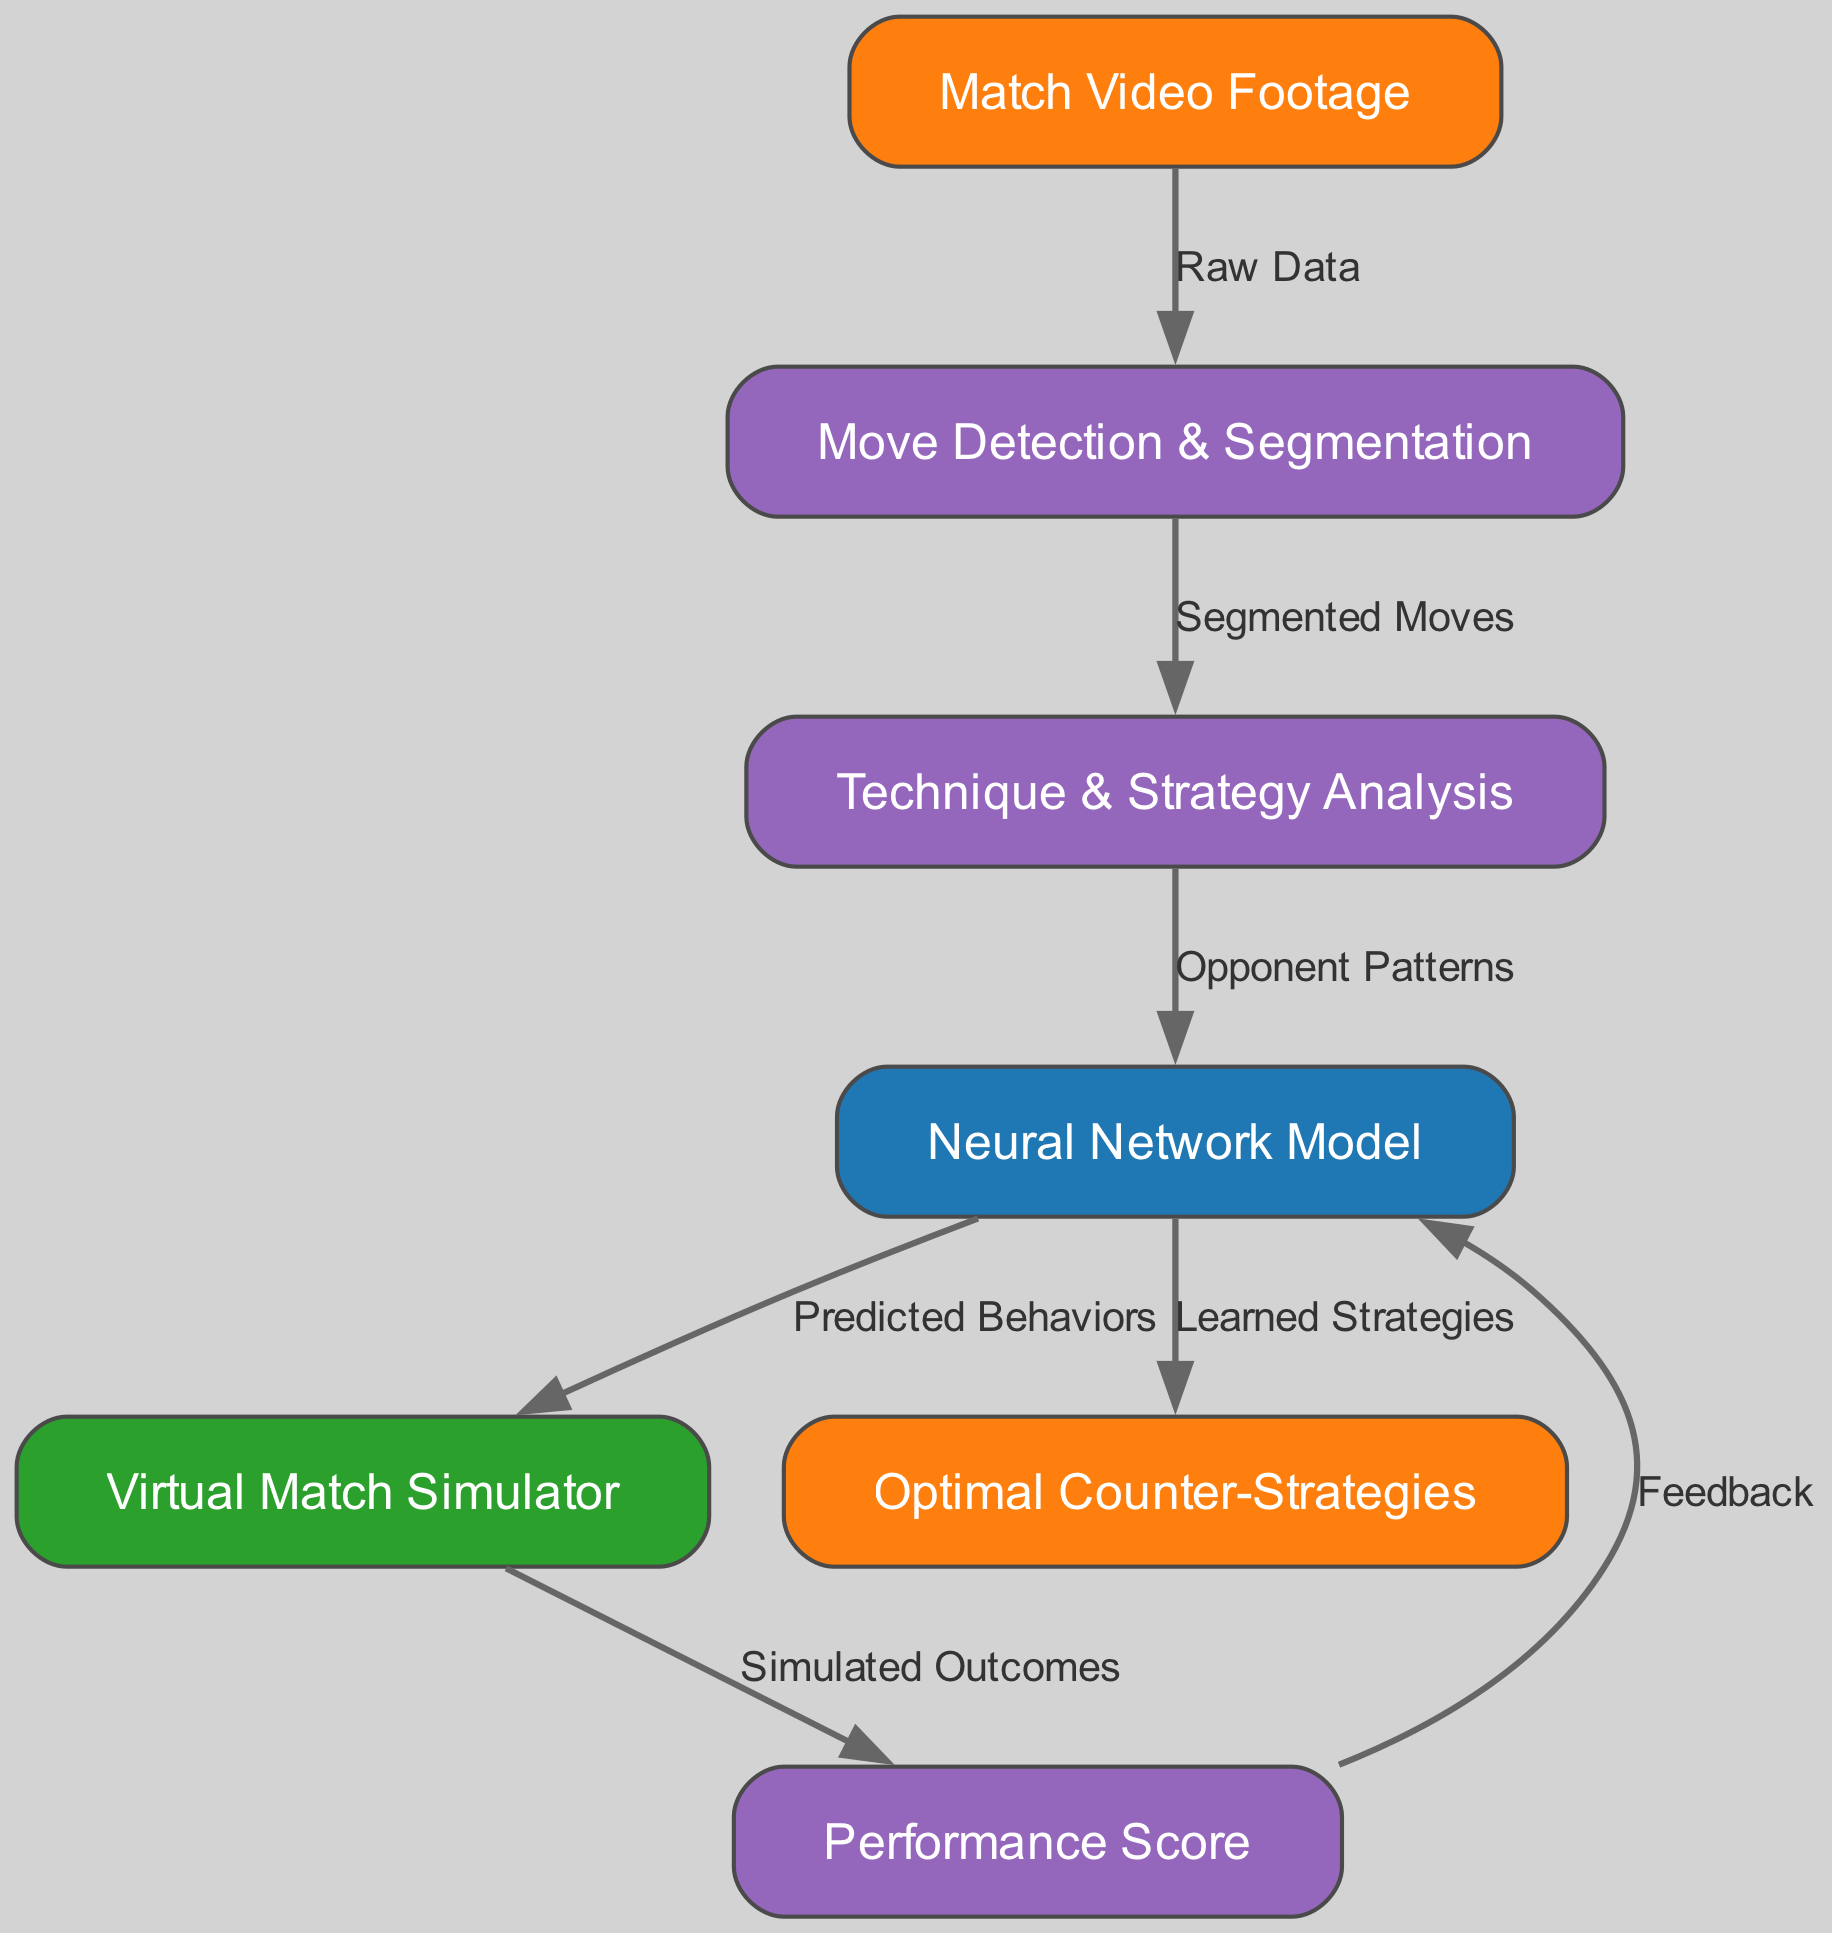What is the starting node of the diagram? The diagram begins with the node labeled "Match Video Footage," which indicates the input to the system.
Answer: Match Video Footage What is the output of the system? The final output node shows "Optimal Counter-Strategies," representing the outcome of the learning process.
Answer: Optimal Counter-Strategies How many nodes are there in the diagram? Count the individual nodes listed in the diagram; there are seven distinct nodes.
Answer: 7 What type of analysis is performed after "Move Detection & Segmentation"? The next node, labeled "Technique & Strategy Analysis," indicates the type of analysis done after move detection.
Answer: Technique & Strategy Analysis Which node receives feedback from the "Performance Score"? The edge indicates that the "Neural Network Model" receives feedback after calculating the performance score.
Answer: Neural Network Model What is the relationship between "Virtual Match Simulator" and "Performance Score"? The flow from "Virtual Match Simulator" to "Performance Score" represents that the virtual match simulator's results generate performance scores upon simulating outcomes.
Answer: Simulated Outcomes What does the "Neural Network Model" produce as output? The model generates "Learned Strategies" as the output after processing the opponent patterns.
Answer: Learned Strategies Which phase follows "Technique & Strategy Analysis"? The "Neural Network Model" follows the "Technique & Strategy Analysis," indicating the next step in utilizing analyzed data.
Answer: Neural Network Model How many edges are present in the diagram? Count all the directed edges connecting the nodes; there are six edges shown in the diagram.
Answer: 6 